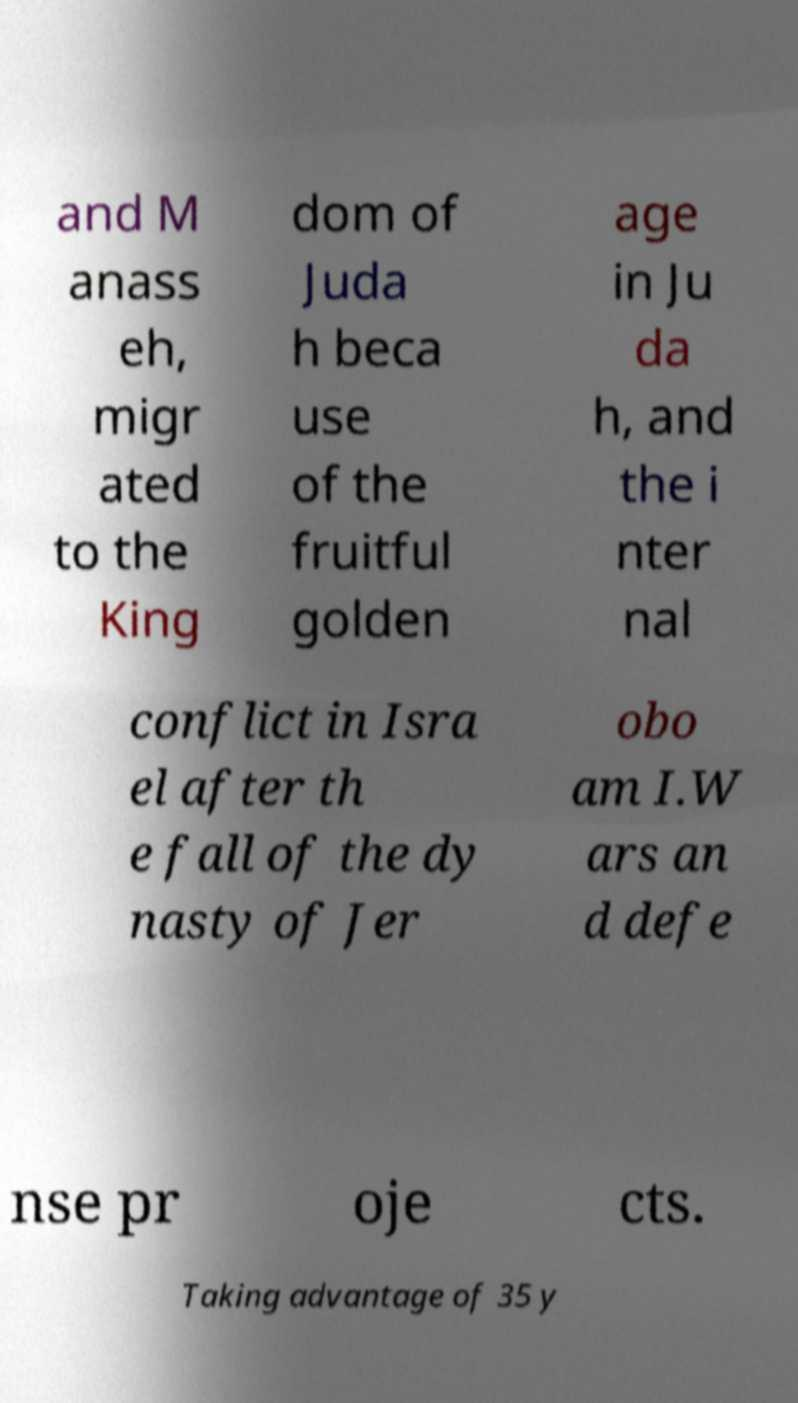Could you extract and type out the text from this image? and M anass eh, migr ated to the King dom of Juda h beca use of the fruitful golden age in Ju da h, and the i nter nal conflict in Isra el after th e fall of the dy nasty of Jer obo am I.W ars an d defe nse pr oje cts. Taking advantage of 35 y 